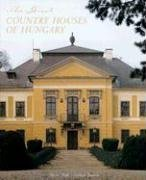What is the title of this book? The book's title is 'The Great Country Houses of Hungary,' which promises a comprehensive exploration of Hungary's most stunning and historically significant estates. 